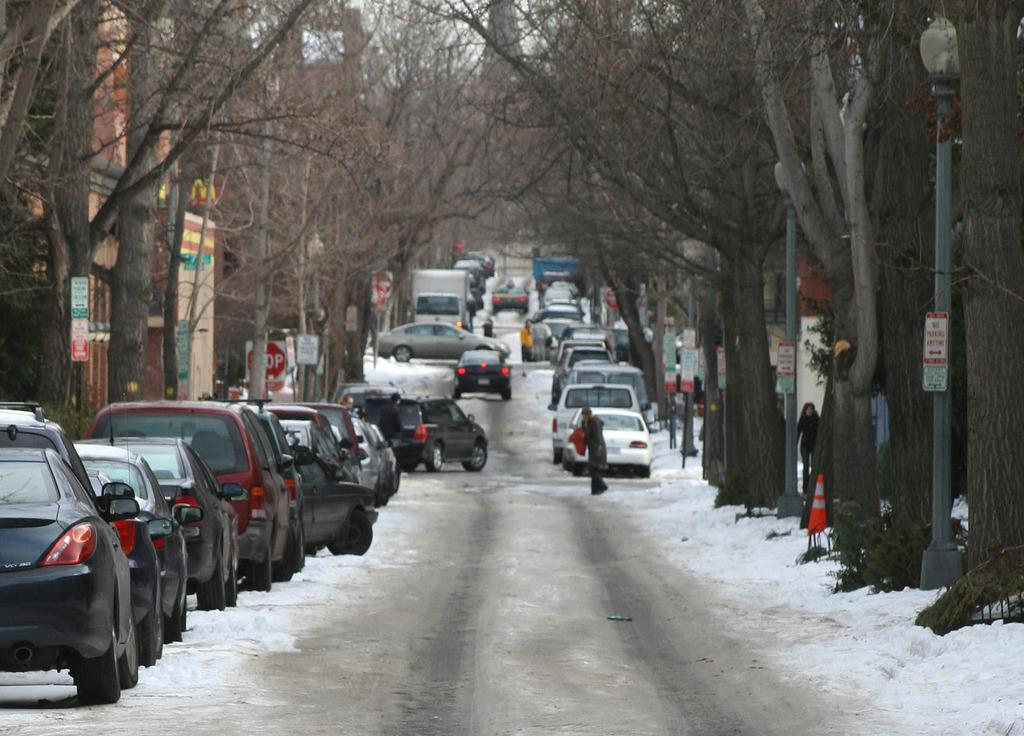What is happening on the road in the image? Vehicles are on the road in the image. Can you describe the people visible in the image? There are people visible in the image. What type of vegetation is present beside the vehicles? There are trees beside the vehicles in the image. What structures are present in the image? Light poles and buildings are visible in the image. What type of information might be conveyed by the signboards in the image? The signboards in the image might convey information about directions, warnings, or advertisements. How many sticks are being used by the people in the image? There are no sticks visible in the image; people are not using any sticks. What type of boats can be seen in the image? There are no boats present in the image. 